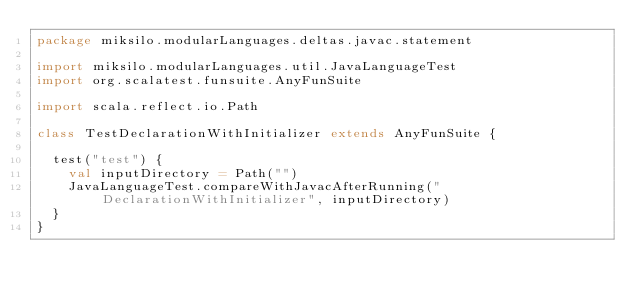<code> <loc_0><loc_0><loc_500><loc_500><_Scala_>package miksilo.modularLanguages.deltas.javac.statement

import miksilo.modularLanguages.util.JavaLanguageTest
import org.scalatest.funsuite.AnyFunSuite

import scala.reflect.io.Path

class TestDeclarationWithInitializer extends AnyFunSuite {

  test("test") {
    val inputDirectory = Path("")
    JavaLanguageTest.compareWithJavacAfterRunning("DeclarationWithInitializer", inputDirectory)
  }
}
</code> 